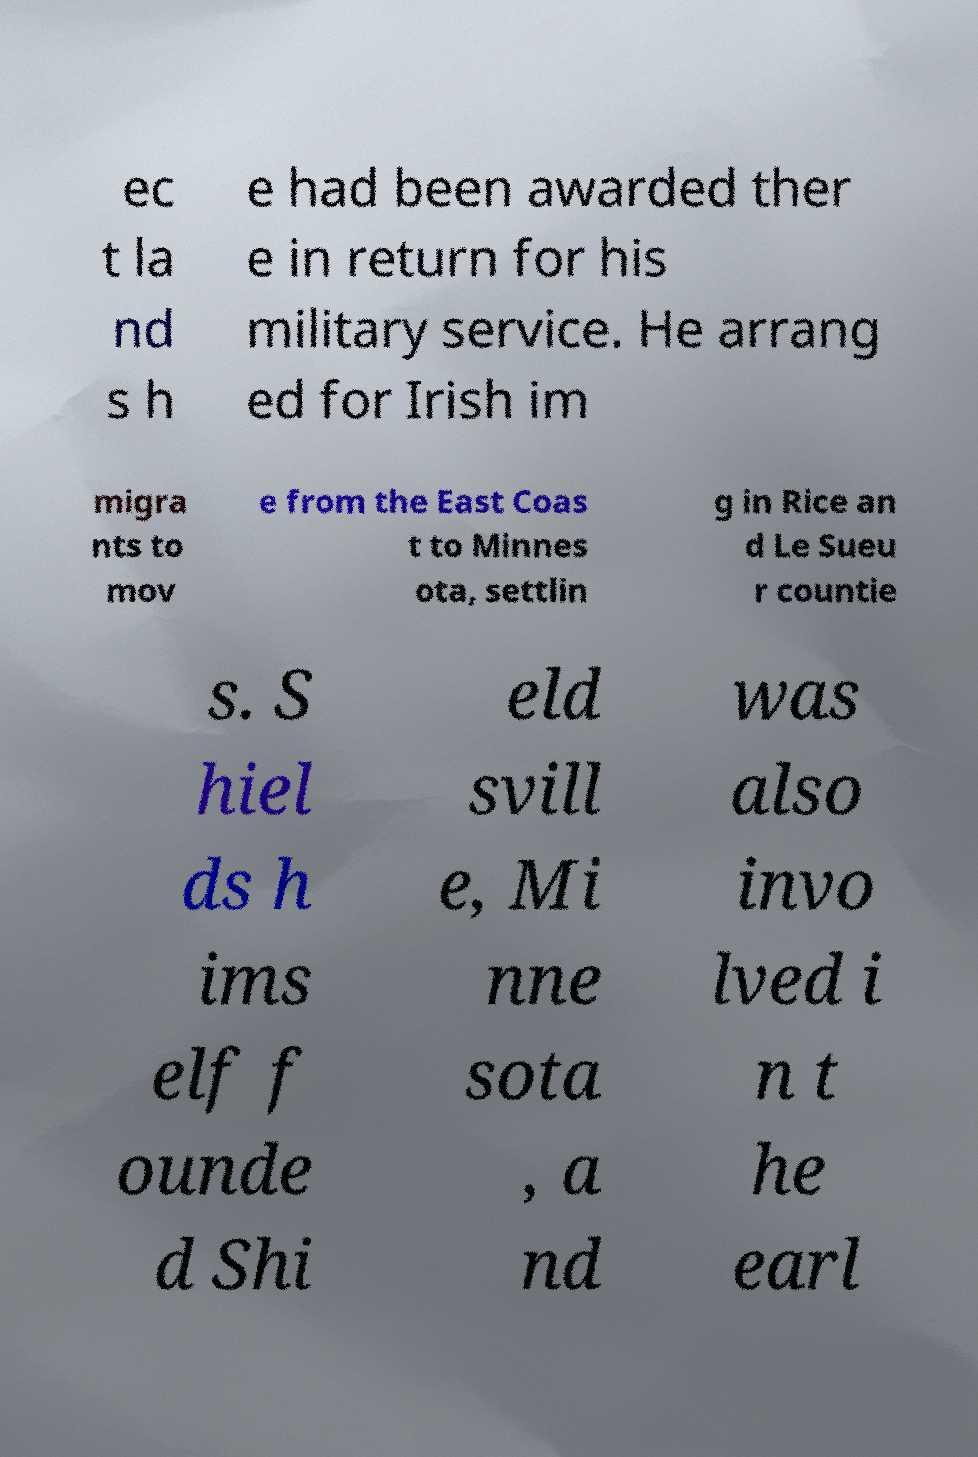Could you assist in decoding the text presented in this image and type it out clearly? ec t la nd s h e had been awarded ther e in return for his military service. He arrang ed for Irish im migra nts to mov e from the East Coas t to Minnes ota, settlin g in Rice an d Le Sueu r countie s. S hiel ds h ims elf f ounde d Shi eld svill e, Mi nne sota , a nd was also invo lved i n t he earl 